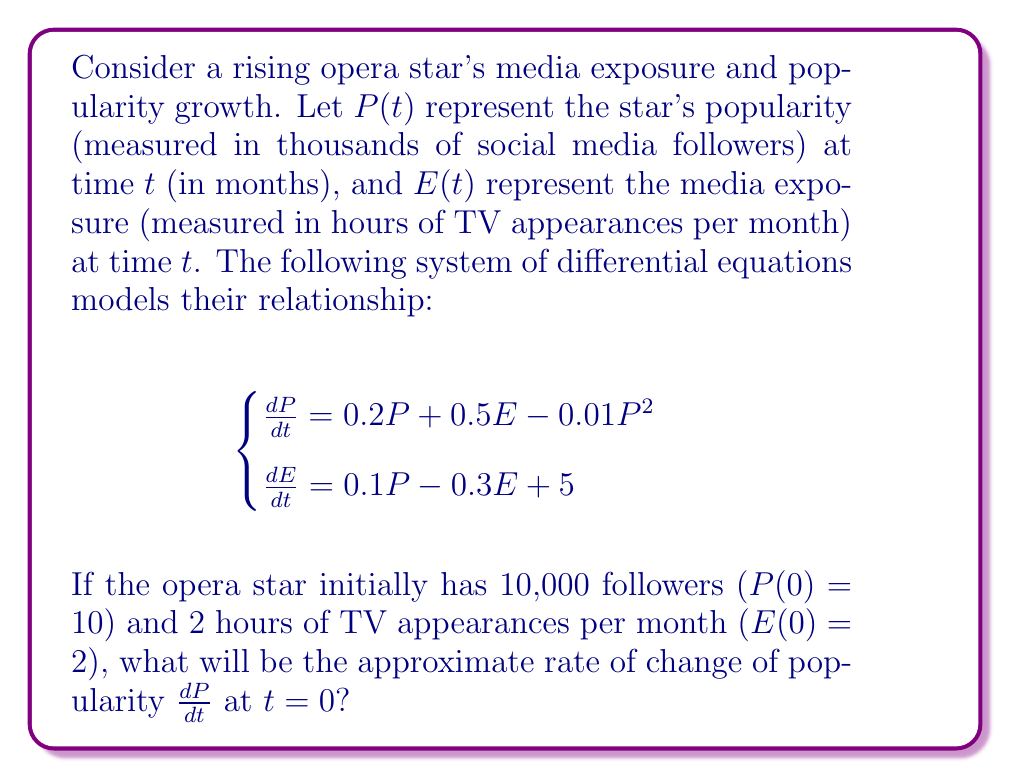Can you solve this math problem? To solve this problem, we need to follow these steps:

1) We have the initial conditions:
   $P(0) = 10$ (10,000 followers)
   $E(0) = 2$ (2 hours of TV appearances)

2) The rate of change of popularity is given by the first equation:
   $$\frac{dP}{dt} = 0.2P + 0.5E - 0.01P^2$$

3) We need to substitute the initial values into this equation:
   $$\frac{dP}{dt} = 0.2(10) + 0.5(2) - 0.01(10)^2$$

4) Let's calculate each term:
   - $0.2(10) = 2$
   - $0.5(2) = 1$
   - $0.01(10)^2 = 0.01(100) = 1$

5) Now we can sum these terms:
   $$\frac{dP}{dt} = 2 + 1 - 1 = 2$$

Therefore, at $t = 0$, the rate of change of popularity $\frac{dP}{dt}$ is 2, which means the opera star's follower count is initially increasing by 2,000 per month.
Answer: $\frac{dP}{dt}(0) = 2$ 